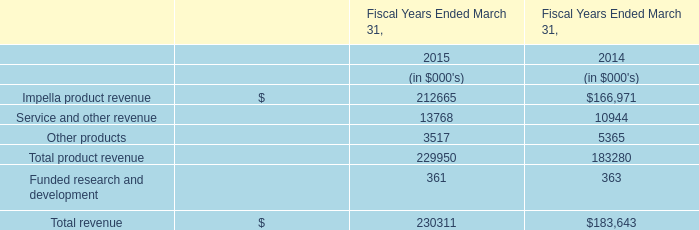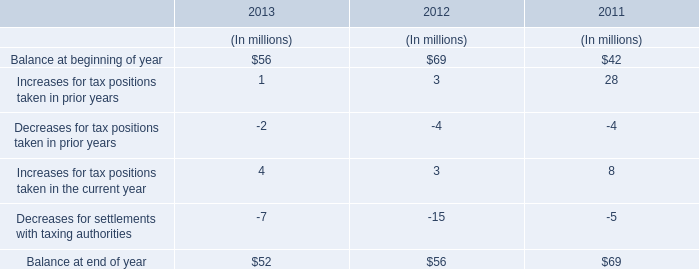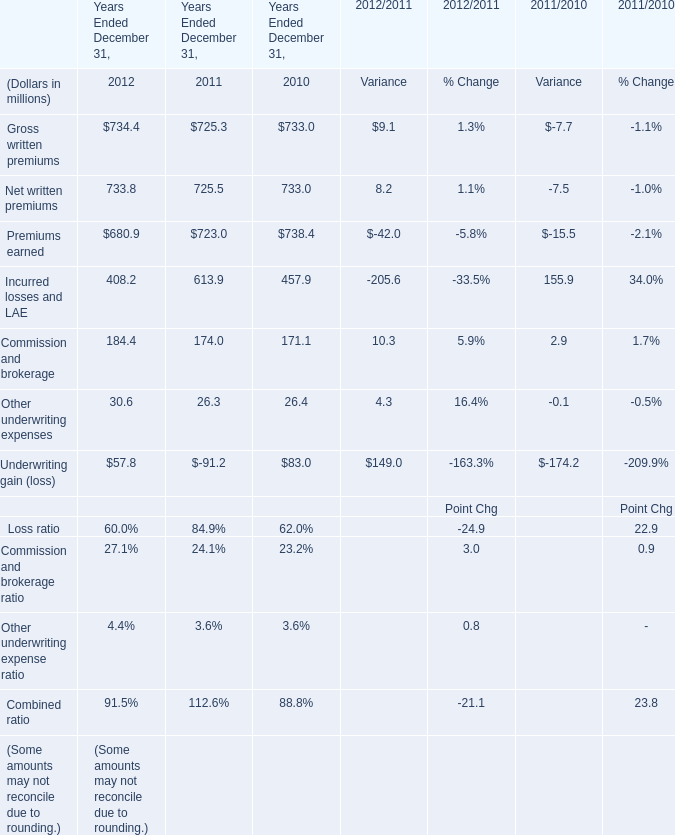In the year with largest amount of Gross written premiums, what's the increasing rate of Other underwriting expenses? 
Computations: ((30.6 - 26.3) / 30.6)
Answer: 0.14052. 